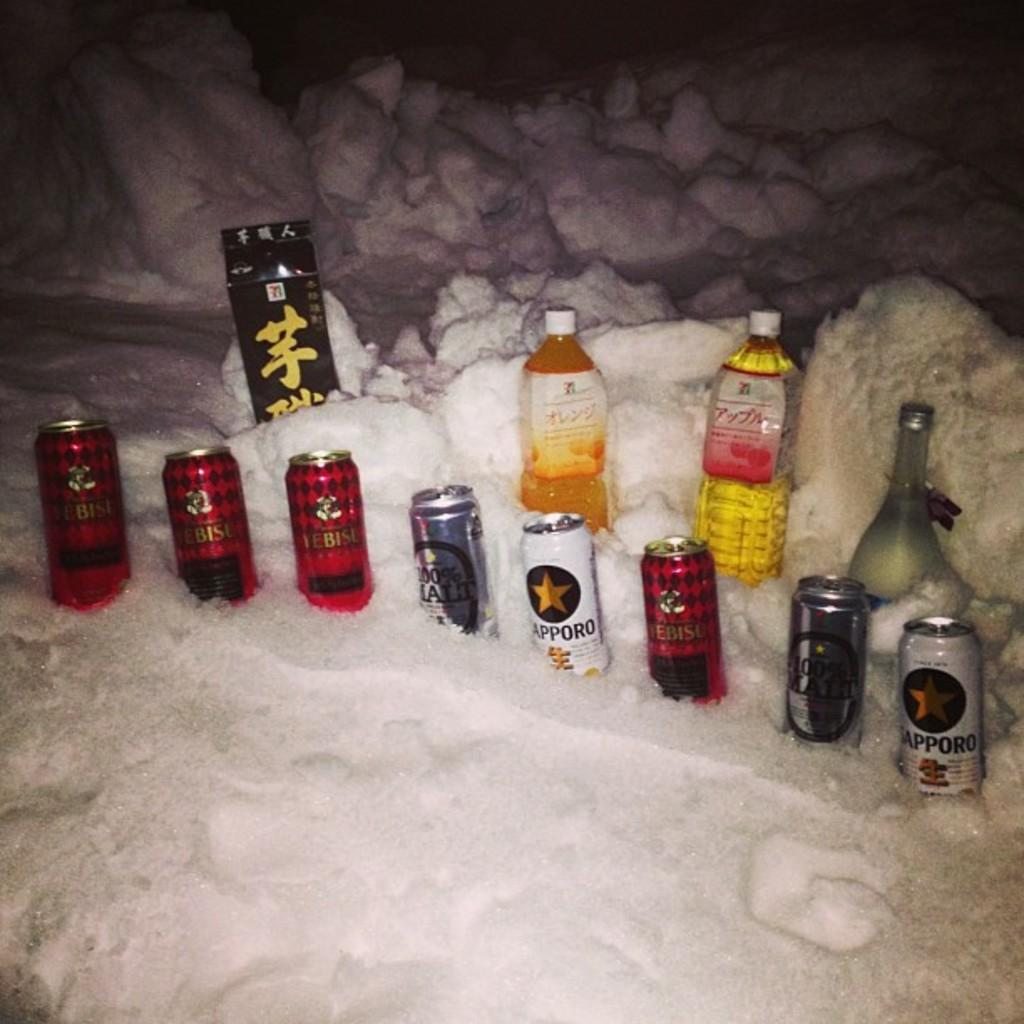<image>
Describe the image concisely. Several bottles lay in the snow, featuring many brands including Apporo. 